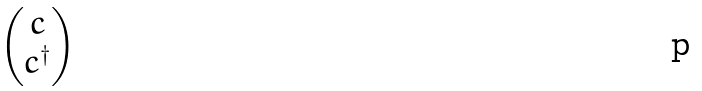Convert formula to latex. <formula><loc_0><loc_0><loc_500><loc_500>\begin{pmatrix} c \\ c ^ { \dagger } \end{pmatrix}</formula> 